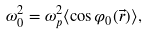<formula> <loc_0><loc_0><loc_500><loc_500>\omega _ { 0 } ^ { 2 } = \omega _ { p } ^ { 2 } \langle \cos \varphi _ { 0 } ( \vec { r } ) \rangle ,</formula> 